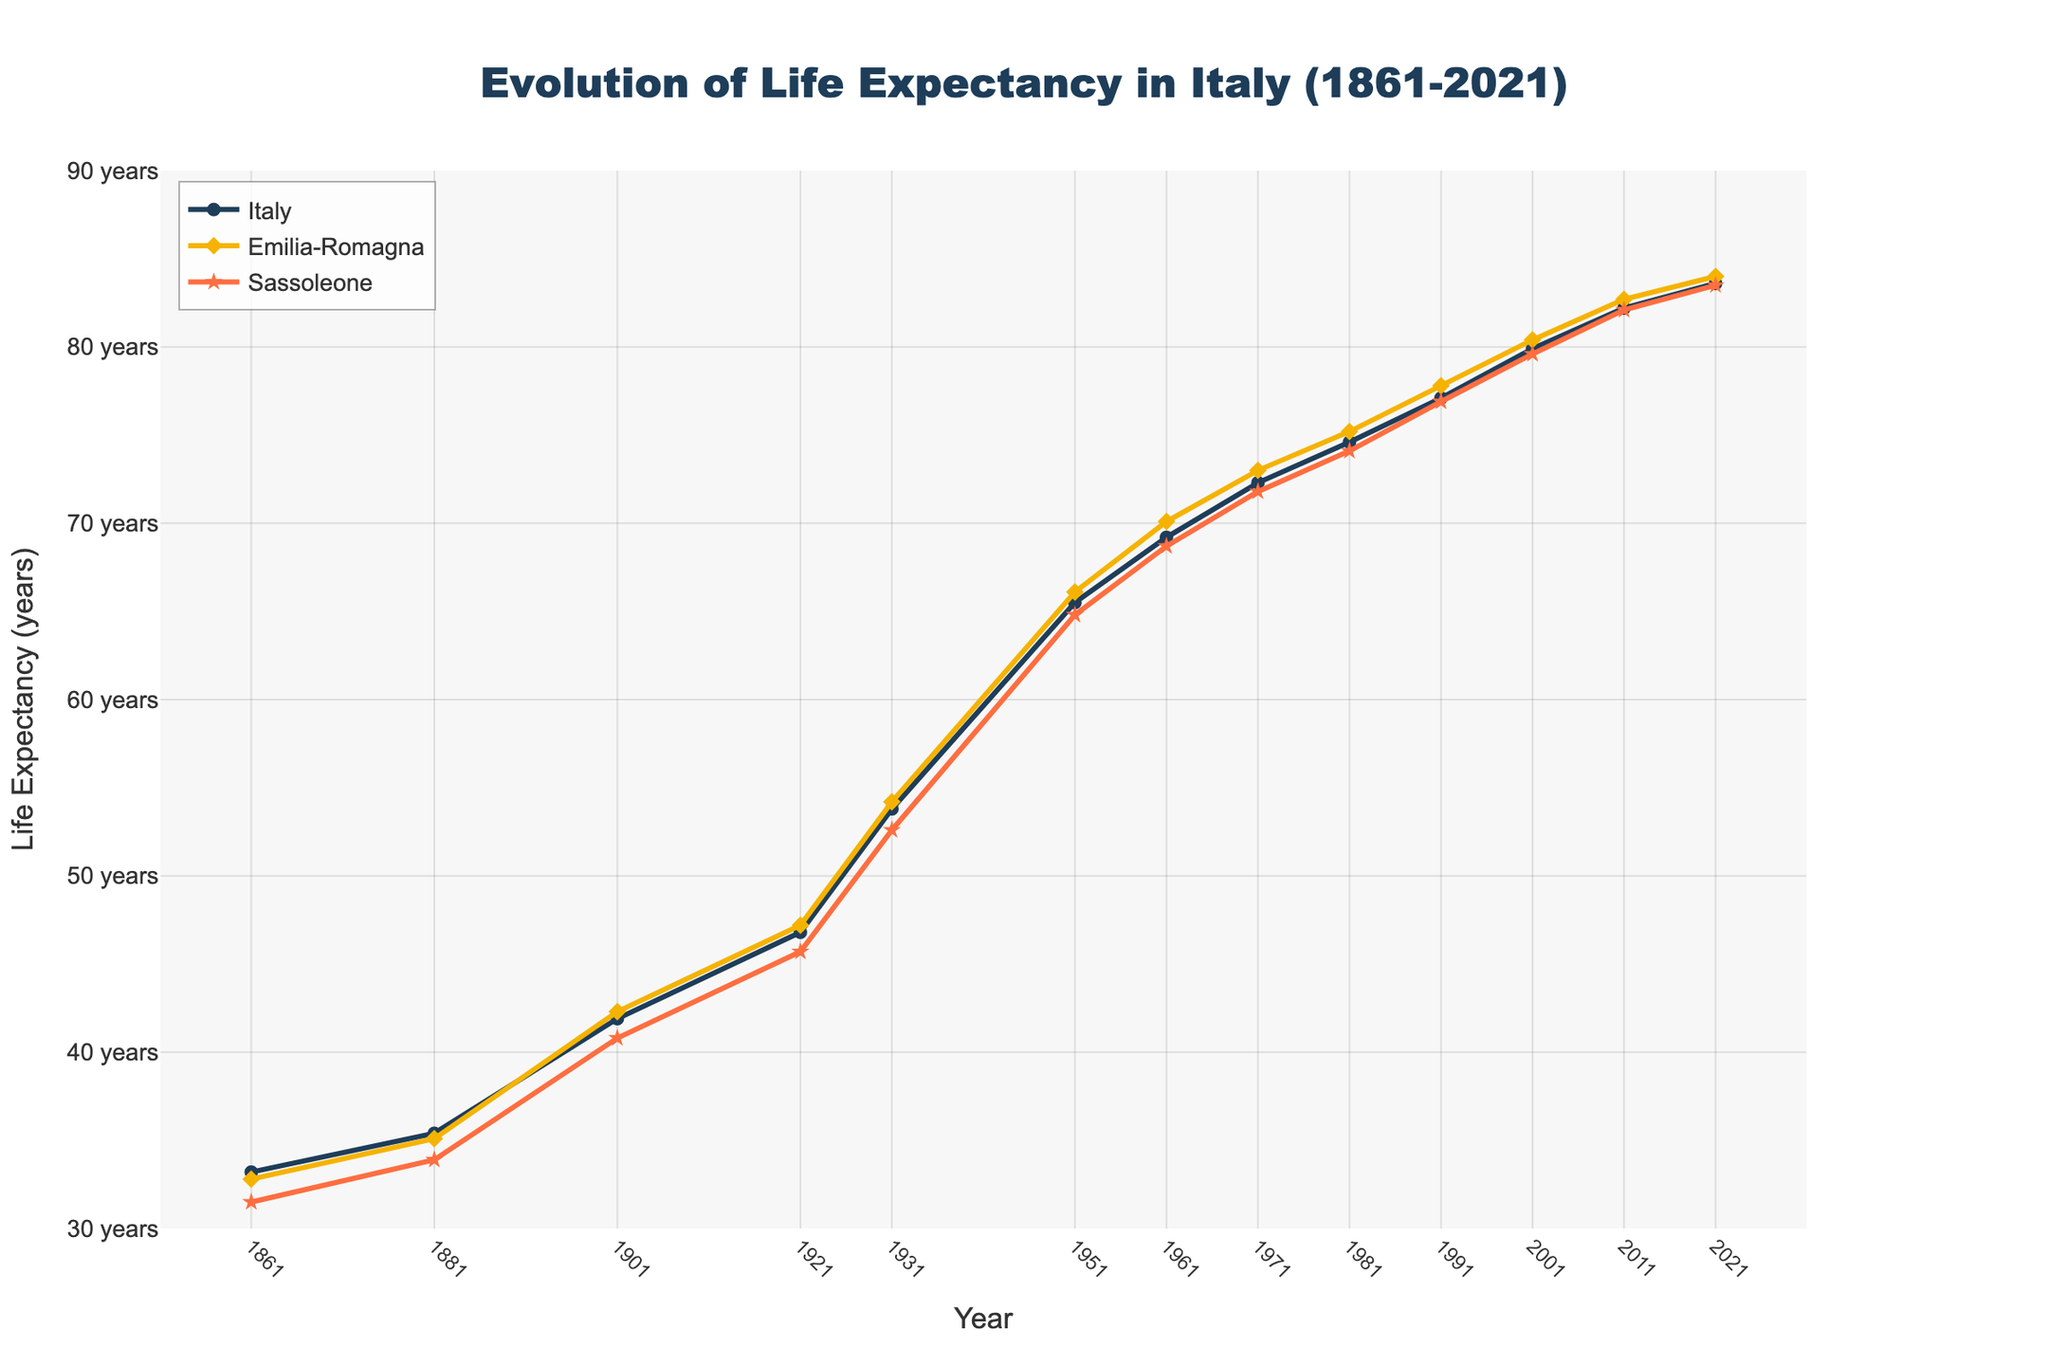What is the overall trend in life expectancy in Italy from 1861 to 2021? The overall trend in life expectancy in Italy shows a steady increase from 33.2 years in 1861 to 83.6 years in 2021. This suggests significant improvements in health and living conditions over the period.
Answer: A steady increase How does life expectancy in Sassoleone in 2021 compare to that in 1861? In 1861, life expectancy in Sassoleone was 31.5 years, and in 2021, it increased to 83.5 years. The comparison shows a dramatic improvement of 52 years.
Answer: 52 years increase Which region had the highest life expectancy in 1931, and what was it? In 1931, Emilia-Romagna had the highest life expectancy among the three compared regions, with a value of 54.2 years.
Answer: Emilia-Romagna, 54.2 years What is the difference in life expectancy between Emilia-Romagna and Sassoleone in 1901? In 1901, the life expectancy in Emilia-Romagna was 42.3 years, and in Sassoleone, it was 40.8 years. The difference is 42.3 - 40.8 = 1.5 years.
Answer: 1.5 years What can be observed about the life expectancy in Italy during the period of 1911-1951? Life expectancy in Italy increased from 46.8 years in 1921 to 65.5 years in 1951, reflecting an improvement over 30 years. This period likely saw significant medical and social advancements.
Answer: It increased significantly Between which decades did Sassoleone see the largest increase in life expectancy? To find the largest increase, compare the differences between consecutive decades: 31.5 to 33.9 (2.4), 33.9 to 40.8 (6.9), 40.8 to 45.7 (4.9), 45.7 to 52.6 (6.9), 52.6 to 64.8 (12.2), 64.8 to 68.7 (3.9), 68.7 to 71.8 (3.1), 71.8 to 74.1 (2.3), 74.1 to 76.9 (2.8), 76.9 to 79.6 (2.7), 79.6 to 82.1 (2.5), 82.1 to 83.5 (1.4). The largest increase was 12.2 years between 1941-1951.
Answer: Between 1941-1951 Is the life expectancy in Emilia-Romagna always higher than in Italy? Examining the graph, the life expectancy in Emilia-Romagna appears consistently slightly higher than in Italy for each recorded year, suggesting better health outcomes in the region.
Answer: Yes How much did the life expectancy in Italy increase between 1951 and 1981? Life expectancy in Italy was 65.5 years in 1951 and increased to 74.6 years in 1981. The increase is 74.6 - 65.5 = 9.1 years.
Answer: 9.1 years In which period did Sassoleone surpass a life expectancy of 70 years? By observing the graph, Sassoleone surpassed a life expectancy of 70 years between 1961 and 1971, specifically reaching 71.8 years in 1971.
Answer: Between 1961 and 1971 